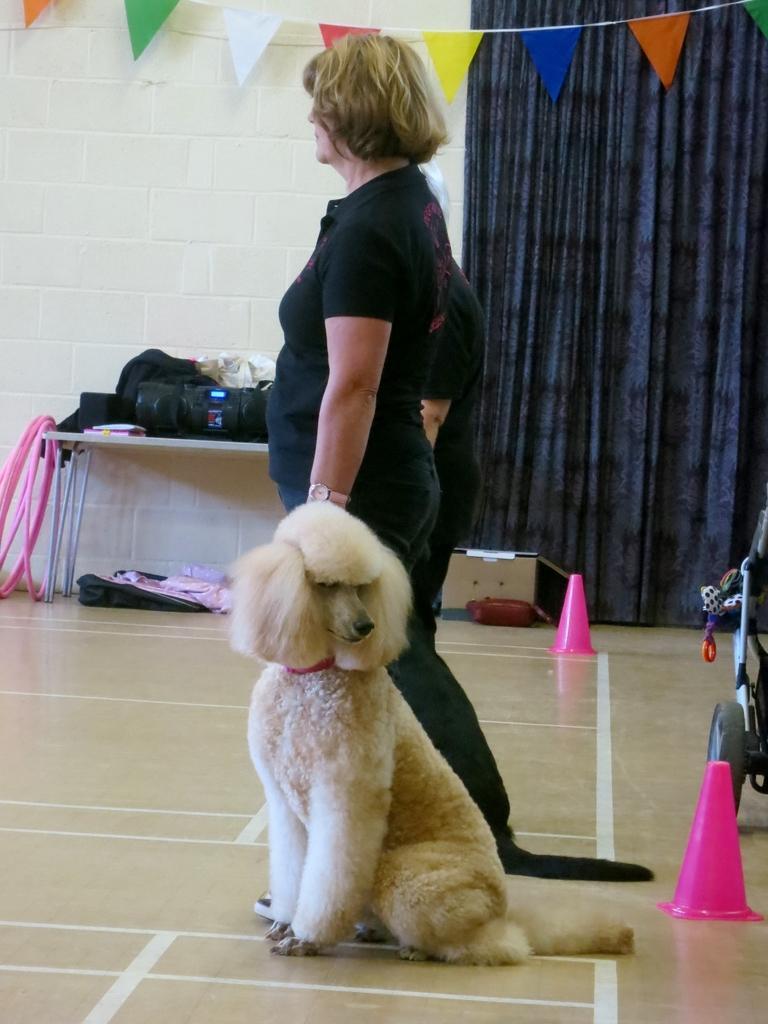Could you give a brief overview of what you see in this image? In this image there is a dog sitting on the floor. In the background there are people, table and curtain. We can see things placed on the table. On the right there are cones and there is a bicycle. At the top there are flags. 